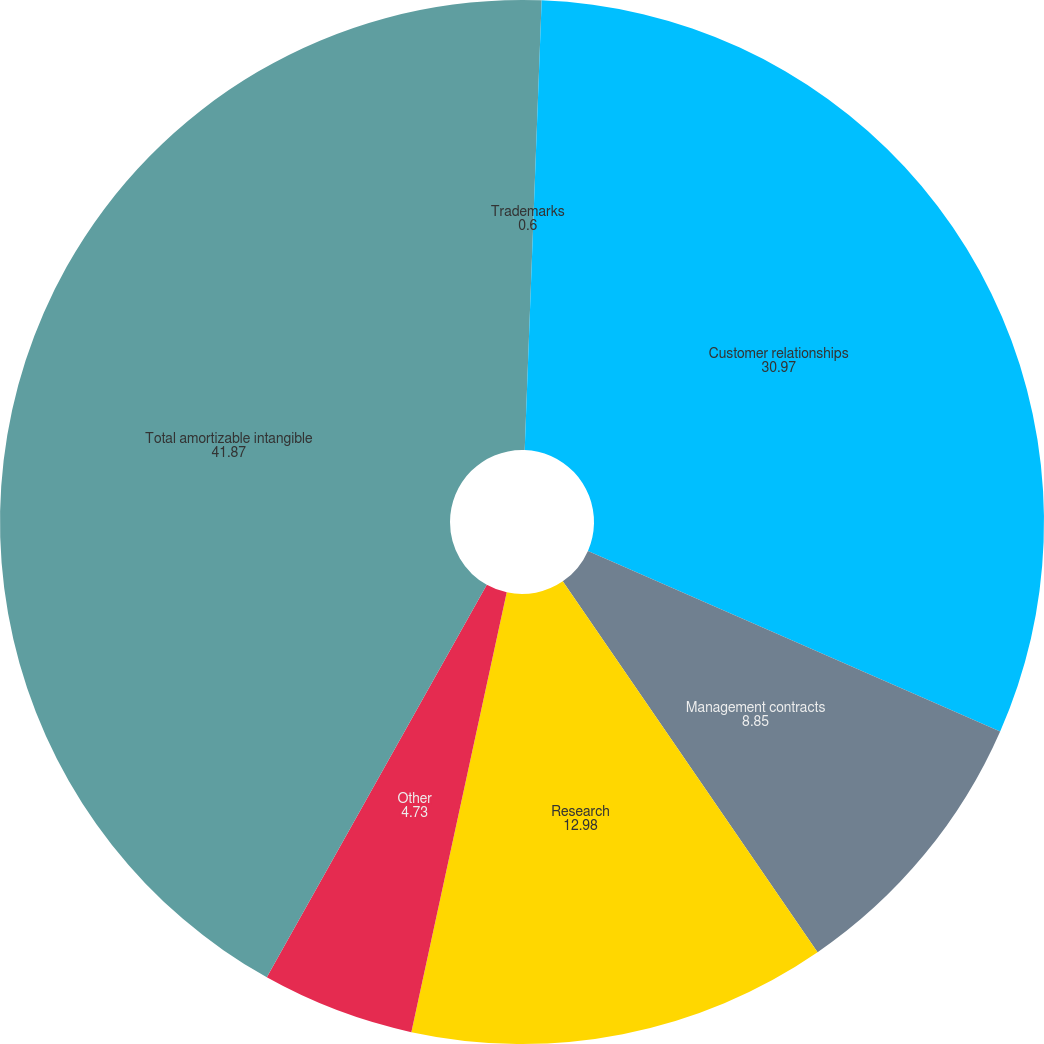<chart> <loc_0><loc_0><loc_500><loc_500><pie_chart><fcel>Trademarks<fcel>Customer relationships<fcel>Management contracts<fcel>Research<fcel>Other<fcel>Total amortizable intangible<nl><fcel>0.6%<fcel>30.97%<fcel>8.85%<fcel>12.98%<fcel>4.73%<fcel>41.87%<nl></chart> 